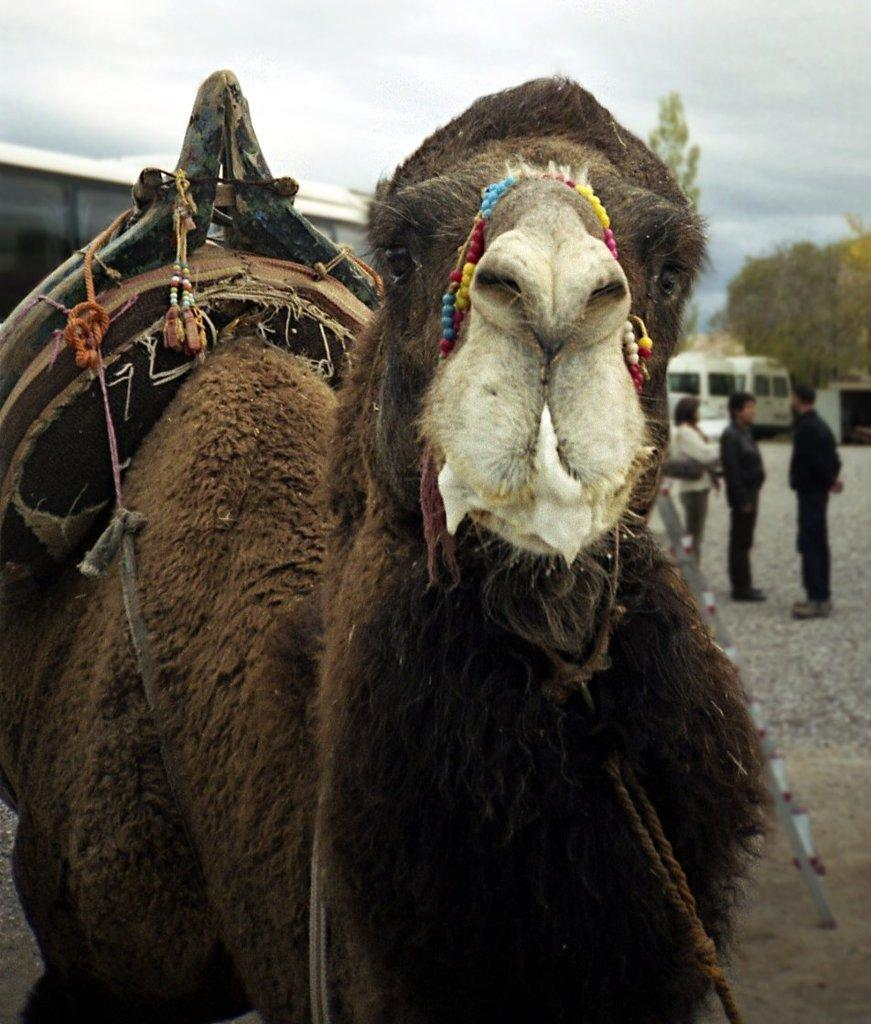What animal is present in the image? There is a camel in the image. What else can be seen in the image besides the camel? There are people standing in the image. What can be seen in the background of the image? There are vehicles, trees, and the sky visible in the background of the image. What is the condition of the sky in the image? The sky is visible in the background of the image, and clouds are present. What type of ship can be seen sailing in the background of the image? There is no ship present in the image; it features a camel, people, vehicles, trees, and a sky with clouds. 